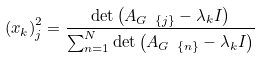Convert formula to latex. <formula><loc_0><loc_0><loc_500><loc_500>\left ( x _ { k } \right ) _ { j } ^ { 2 } = \frac { \det \left ( A _ { G \ \left \{ j \right \} } - \lambda _ { k } I \right ) } { \sum _ { n = 1 } ^ { N } \det \left ( A _ { G \ \left \{ n \right \} } - \lambda _ { k } I \right ) }</formula> 